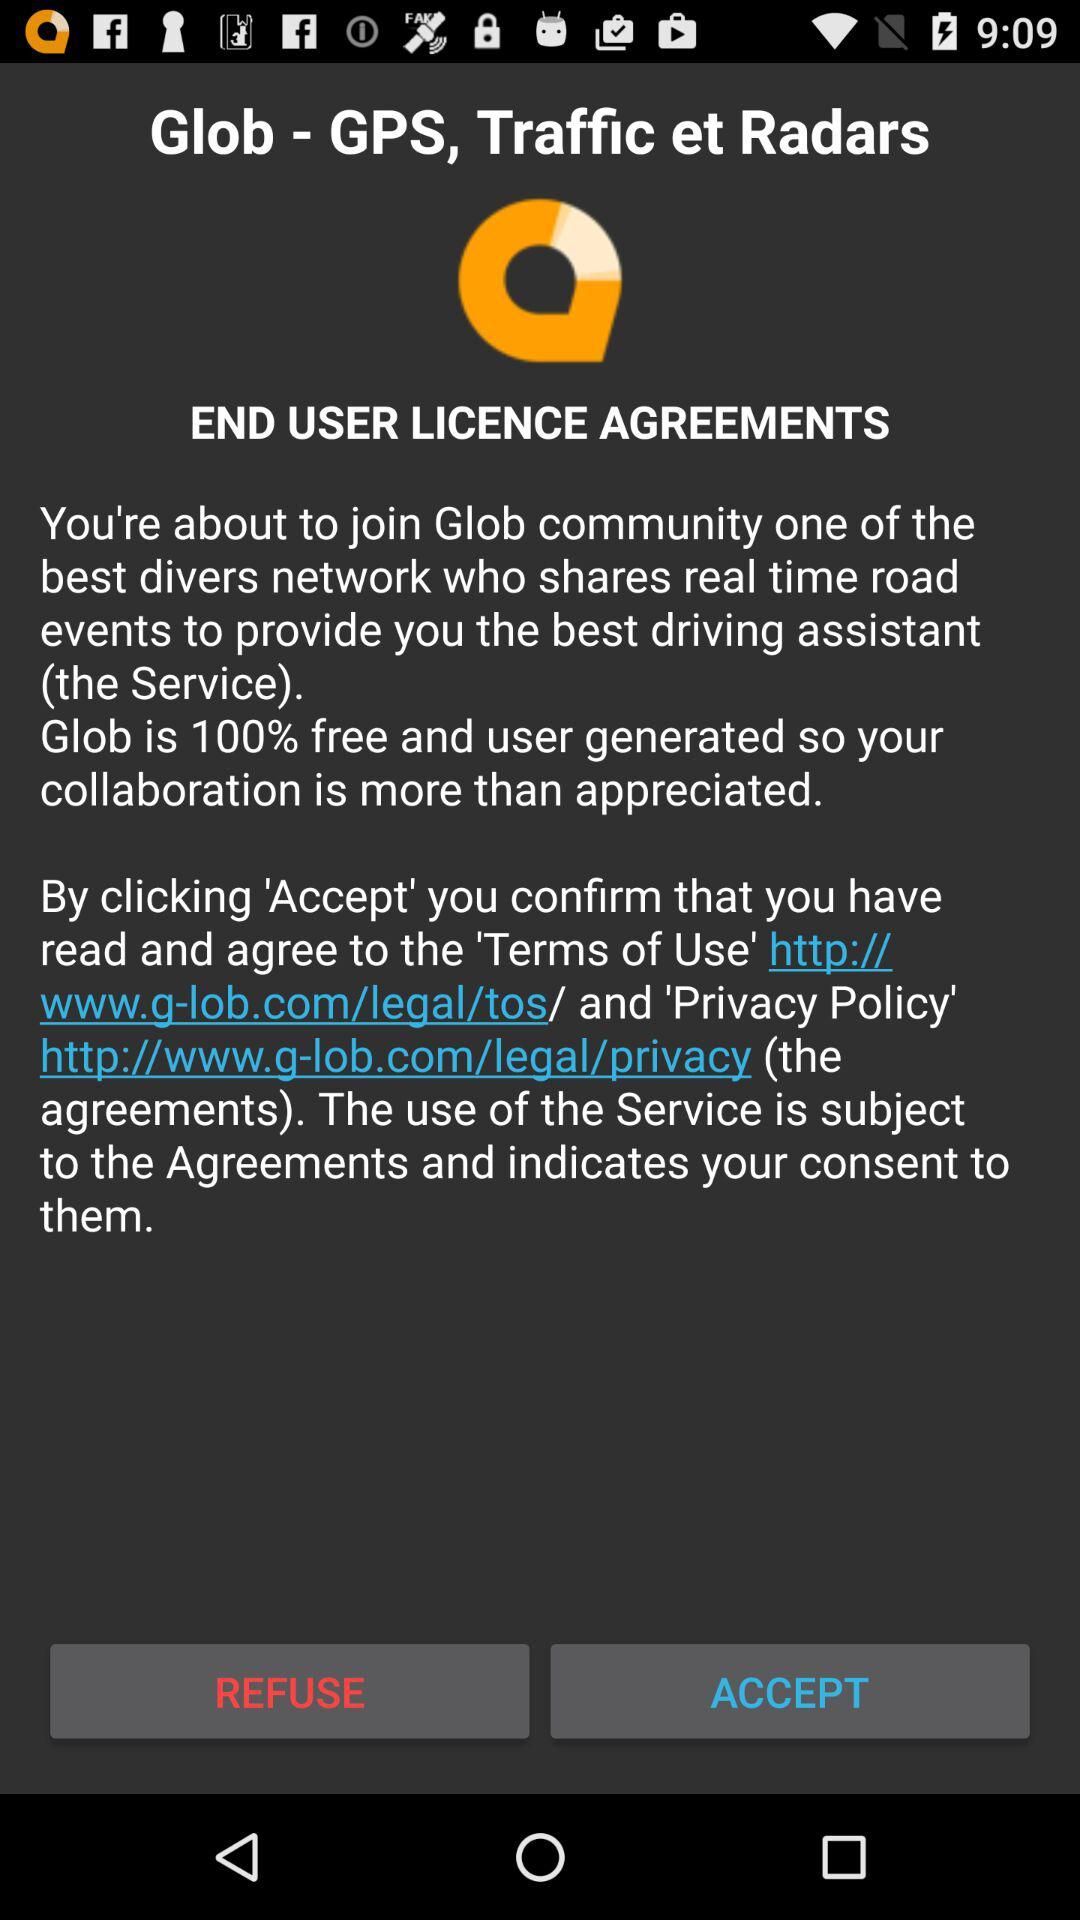What is the name of the application? The name of the application is "Glob - GPS, Traffic et Radars". 